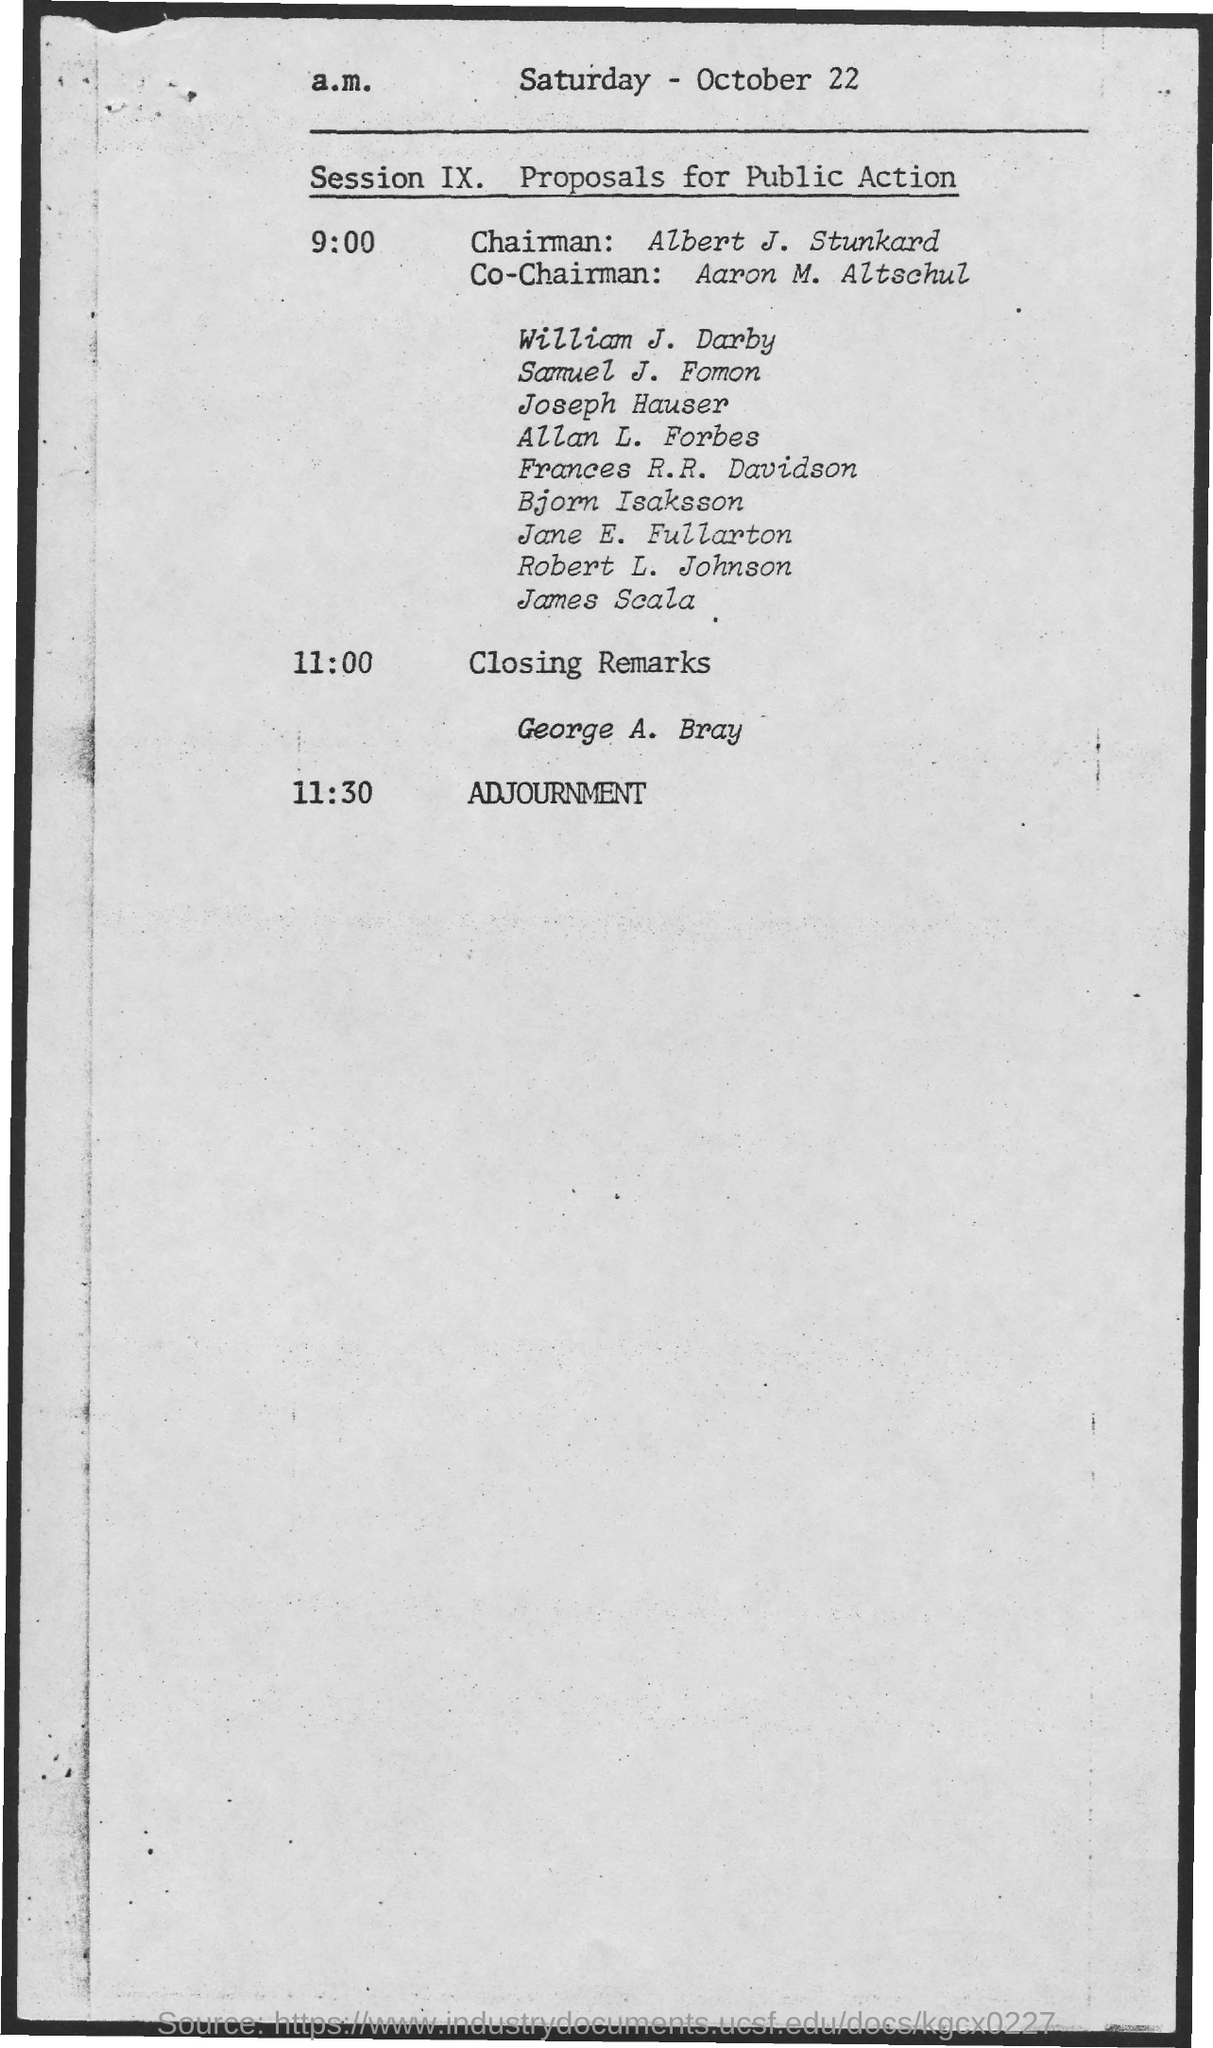Point out several critical features in this image. At 11.30, the time for adjournment has been scheduled. The document mentions Saturday as the day of the week. Albert J. Stunkard is the chairman. The co-chairman is Aaron M. Altschul. George A. Bray is giving the closing remarks. 